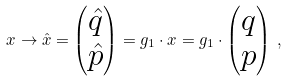<formula> <loc_0><loc_0><loc_500><loc_500>x \to \hat { x } = \begin{pmatrix} \hat { q } \\ \hat { p } \end{pmatrix} = g _ { 1 } \cdot x = g _ { 1 } \cdot \begin{pmatrix} q \\ p \end{pmatrix} \, ,</formula> 